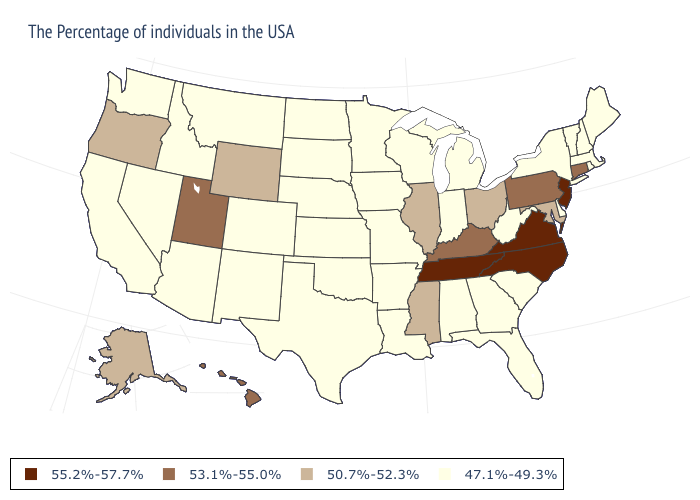Does New Mexico have a lower value than Colorado?
Be succinct. No. What is the value of North Dakota?
Answer briefly. 47.1%-49.3%. What is the highest value in the USA?
Quick response, please. 55.2%-57.7%. Does the first symbol in the legend represent the smallest category?
Quick response, please. No. What is the highest value in the USA?
Short answer required. 55.2%-57.7%. Which states have the lowest value in the USA?
Write a very short answer. Maine, Massachusetts, Rhode Island, New Hampshire, Vermont, New York, Delaware, South Carolina, West Virginia, Florida, Georgia, Michigan, Indiana, Alabama, Wisconsin, Louisiana, Missouri, Arkansas, Minnesota, Iowa, Kansas, Nebraska, Oklahoma, Texas, South Dakota, North Dakota, Colorado, New Mexico, Montana, Arizona, Idaho, Nevada, California, Washington. Does Arizona have the lowest value in the USA?
Concise answer only. Yes. What is the lowest value in states that border Minnesota?
Give a very brief answer. 47.1%-49.3%. Does Ohio have the highest value in the MidWest?
Answer briefly. Yes. Which states have the lowest value in the MidWest?
Be succinct. Michigan, Indiana, Wisconsin, Missouri, Minnesota, Iowa, Kansas, Nebraska, South Dakota, North Dakota. What is the value of Hawaii?
Give a very brief answer. 53.1%-55.0%. Is the legend a continuous bar?
Write a very short answer. No. Does Vermont have a higher value than Kansas?
Answer briefly. No. Among the states that border Missouri , does Tennessee have the lowest value?
Give a very brief answer. No. 